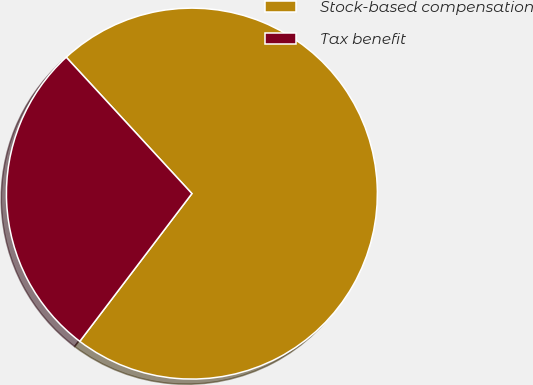Convert chart. <chart><loc_0><loc_0><loc_500><loc_500><pie_chart><fcel>Stock-based compensation<fcel>Tax benefit<nl><fcel>72.18%<fcel>27.82%<nl></chart> 